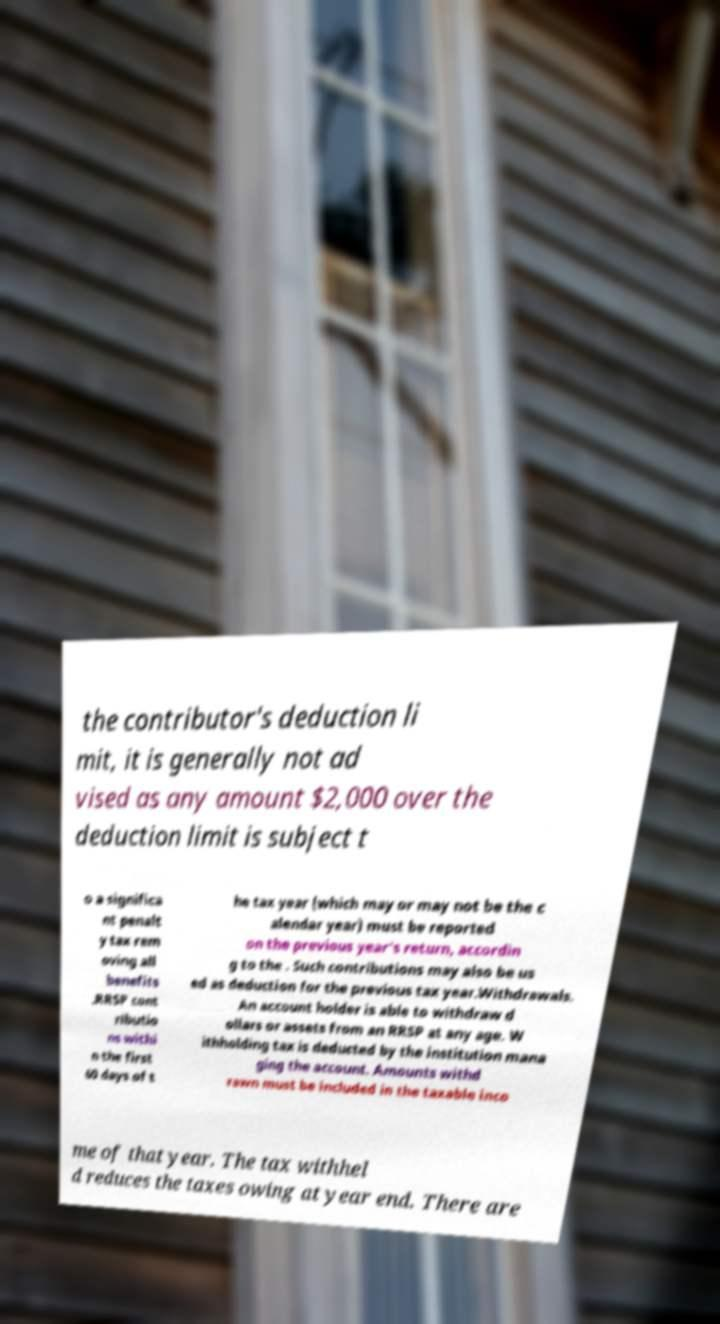Can you read and provide the text displayed in the image?This photo seems to have some interesting text. Can you extract and type it out for me? the contributor's deduction li mit, it is generally not ad vised as any amount $2,000 over the deduction limit is subject t o a significa nt penalt y tax rem oving all benefits .RRSP cont ributio ns withi n the first 60 days of t he tax year (which may or may not be the c alendar year) must be reported on the previous year's return, accordin g to the . Such contributions may also be us ed as deduction for the previous tax year.Withdrawals. An account holder is able to withdraw d ollars or assets from an RRSP at any age. W ithholding tax is deducted by the institution mana ging the account. Amounts withd rawn must be included in the taxable inco me of that year. The tax withhel d reduces the taxes owing at year end. There are 